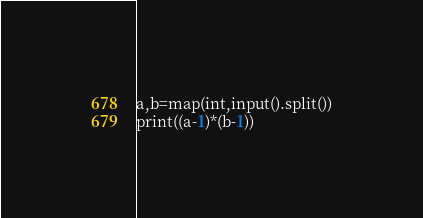Convert code to text. <code><loc_0><loc_0><loc_500><loc_500><_Python_>a,b=map(int,input().split())
print((a-1)*(b-1))</code> 